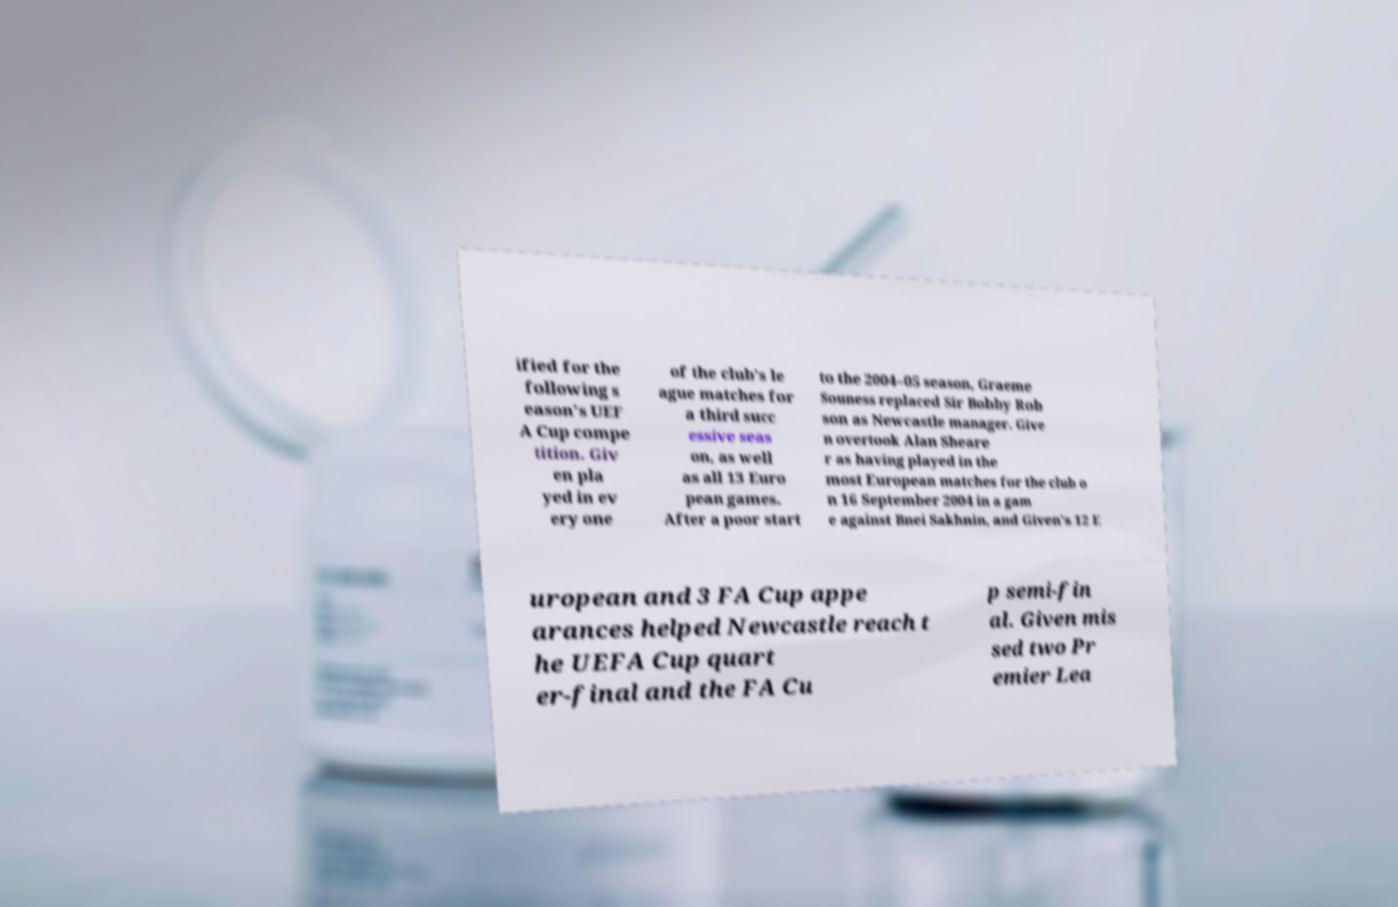For documentation purposes, I need the text within this image transcribed. Could you provide that? ified for the following s eason's UEF A Cup compe tition. Giv en pla yed in ev ery one of the club's le ague matches for a third succ essive seas on, as well as all 13 Euro pean games. After a poor start to the 2004–05 season, Graeme Souness replaced Sir Bobby Rob son as Newcastle manager. Give n overtook Alan Sheare r as having played in the most European matches for the club o n 16 September 2004 in a gam e against Bnei Sakhnin, and Given's 12 E uropean and 3 FA Cup appe arances helped Newcastle reach t he UEFA Cup quart er-final and the FA Cu p semi-fin al. Given mis sed two Pr emier Lea 